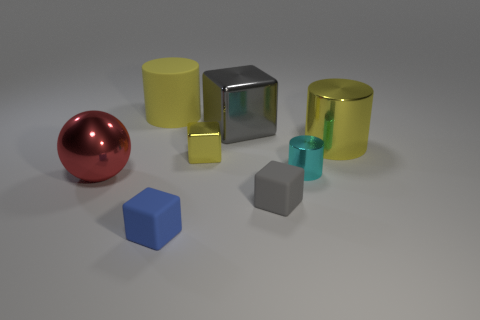What number of small objects are both behind the blue cube and in front of the red shiny object?
Provide a short and direct response. 1. The small matte object on the left side of the gray rubber object has what shape?
Provide a short and direct response. Cube. What number of tiny yellow cubes have the same material as the red sphere?
Offer a very short reply. 1. There is a small cyan object; is it the same shape as the large yellow thing that is to the left of the cyan object?
Offer a terse response. Yes. Is there a matte block on the right side of the tiny object in front of the gray block that is in front of the small cyan cylinder?
Your answer should be compact. Yes. How big is the yellow thing on the left side of the blue rubber object?
Give a very brief answer. Large. What is the material of the gray block that is the same size as the blue matte cube?
Your response must be concise. Rubber. Does the large yellow rubber object have the same shape as the red thing?
Your answer should be compact. No. How many objects are either tiny yellow things or big objects that are behind the gray matte block?
Offer a very short reply. 5. What material is the other cylinder that is the same color as the large rubber cylinder?
Ensure brevity in your answer.  Metal. 